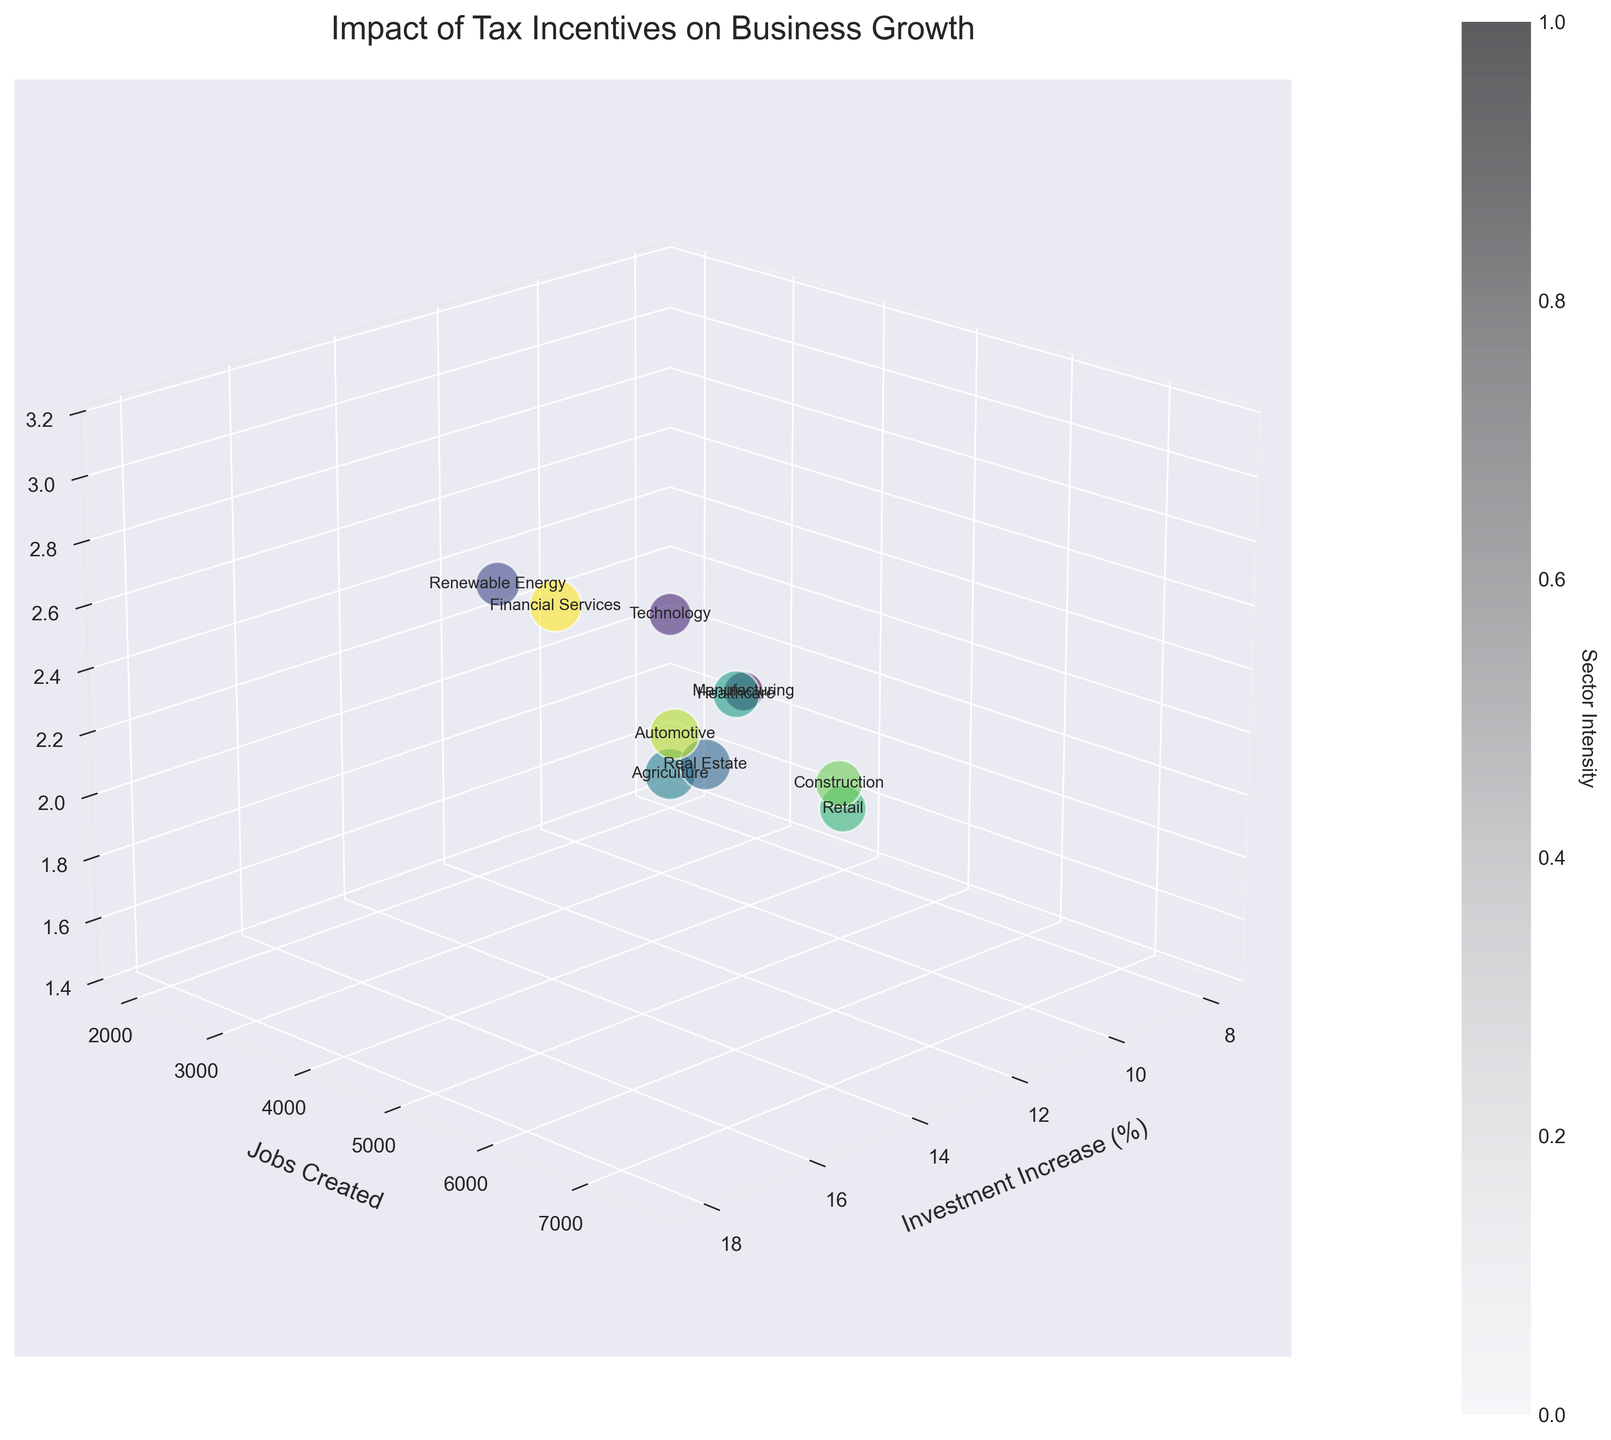What is the title of the chart? The title of the chart is typically found at the top of the figure, providing a clear description of what the chart is about. Here, we can see the title reads "Impact of Tax Incentives on Business Growth."
Answer: Impact of Tax Incentives on Business Growth Which tax incentive sector created the most jobs? By looking at the "Jobs Created" axis and finding the highest value, we see that the Technology sector with the Startup Deduction created the most jobs, which is 7500.
Answer: Technology What is the tax incentive sector with the lowest economic growth percentage? On the "Economic Growth (%)" axis, the lowest value is observed. For Real Estate with Opportunity Zone Investment, the economic growth is 1.8%.
Answer: Real Estate How many sectors appear in the figure? Counting the number of labeled points corresponding to different sectors in the chart, we find there are 10 sectors represented.
Answer: 10 Which sector shows the highest increase in investment percentage? By examining the "Investment Increase (%)" axis, the highest value is seen for the Technology sector, which has an increase of 18%.
Answer: Technology What is the relationship between job creation and economic growth for the Healthcare sector? Looking at the dot labeled "Healthcare," you’ll find it has 6000 jobs created and an economic growth of 2.5%.
Answer: 6000, 2.5% Which sector has more jobs created than Renewable Energy but less economic growth than Manufacturing? Checking the sectors point by point, we see that Construction with 5500 jobs created has more jobs than Renewable Energy (4000) and less economic growth (2.0%) than Manufacturing (2.3%).
Answer: Construction What can be inferred about sectors with higher investment increases and their job creation figures? Observing the clusters, it’s clear that sectors with higher investment increases, e.g., Technology and Financial Services, also tend to show higher job creation figures, ranging from 5200 to 7500 jobs.
Answer: Sectors with higher investment typically create more jobs How does the Retail sector compare in job creation and economic growth to the Construction sector? Retail has 4500 jobs created and 1.7% economic growth, while Construction has 5500 jobs and 2.0% economic growth.
Answer: Construction has more What is the color scheme used in the chart to differentiate sectors? The color for each sector is picked from a gradual color scale (viridis colormap), transitioning from one color to another, ensuring an easy visual distinction between different sectors.
Answer: Viridis colormap 